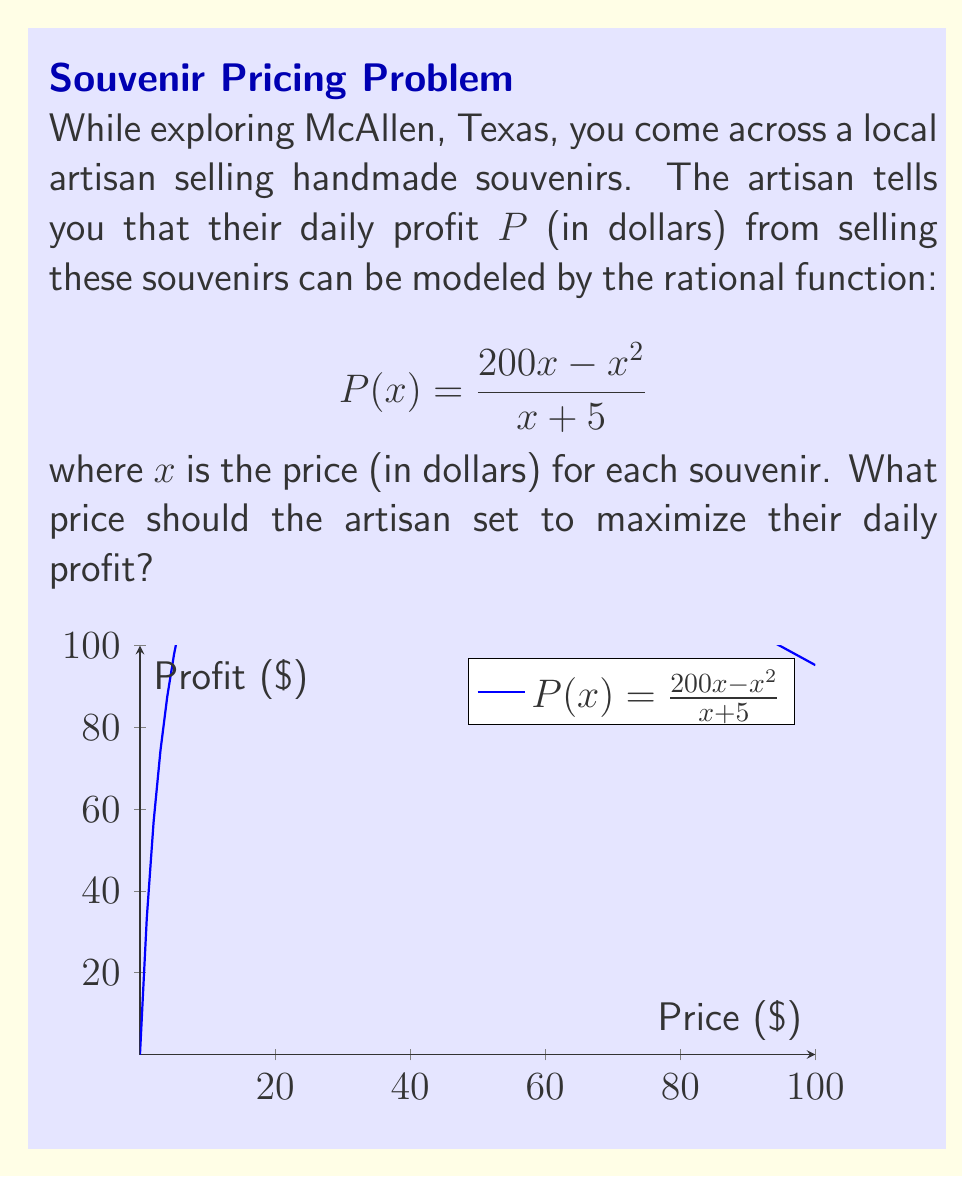Can you solve this math problem? To find the optimal price, we need to follow these steps:

1) First, we need to find the derivative of the profit function $P(x)$.

   $$P(x) = \frac{200x - x^2}{x + 5}$$

   Using the quotient rule, we get:

   $$P'(x) = \frac{(200 - 2x)(x + 5) - (200x - x^2)(1)}{(x + 5)^2}$$

2) Simplify the numerator:

   $$P'(x) = \frac{200x + 1000 - 2x^2 - 10x - 200x + x^2}{(x + 5)^2}$$
   $$P'(x) = \frac{-x^2 - 10x + 1000}{(x + 5)^2}$$

3) To find the maximum profit, we set $P'(x) = 0$ and solve for $x$:

   $$\frac{-x^2 - 10x + 1000}{(x + 5)^2} = 0$$

4) The denominator is always positive for real $x > -5$, so we only need to solve:

   $$-x^2 - 10x + 1000 = 0$$

5) This is a quadratic equation. We can solve it using the quadratic formula:

   $$x = \frac{-b \pm \sqrt{b^2 - 4ac}}{2a}$$

   where $a = -1$, $b = -10$, and $c = 1000$

6) Plugging in these values:

   $$x = \frac{10 \pm \sqrt{100 + 4000}}{-2} = \frac{10 \pm \sqrt{4100}}{-2}$$

7) Simplifying:

   $$x = \frac{10 \pm 64.03}{-2}$$

8) This gives us two solutions:
   
   $x_1 = -37.02$ and $x_2 = 27.02$

9) Since price cannot be negative, we discard the negative solution.

Therefore, the optimal price is approximately $27.02.
Answer: $27.02 